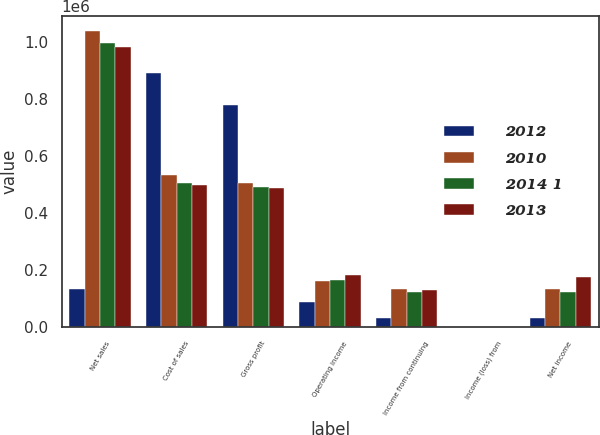<chart> <loc_0><loc_0><loc_500><loc_500><stacked_bar_chart><ecel><fcel>Net sales<fcel>Cost of sales<fcel>Gross profit<fcel>Operating income<fcel>Income from continuing<fcel>Income (loss) from<fcel>Net income<nl><fcel>2012<fcel>134358<fcel>892547<fcel>778025<fcel>88590<fcel>32429<fcel>0<fcel>32429<nl><fcel>2010<fcel>1.03816e+06<fcel>534549<fcel>503610<fcel>160264<fcel>134225<fcel>0<fcel>134358<nl><fcel>2014 1<fcel>996168<fcel>504524<fcel>491644<fcel>164351<fcel>121897<fcel>0.02<fcel>122904<nl><fcel>2013<fcel>983488<fcel>496719<fcel>486769<fcel>182036<fcel>130343<fcel>0.82<fcel>174643<nl></chart> 